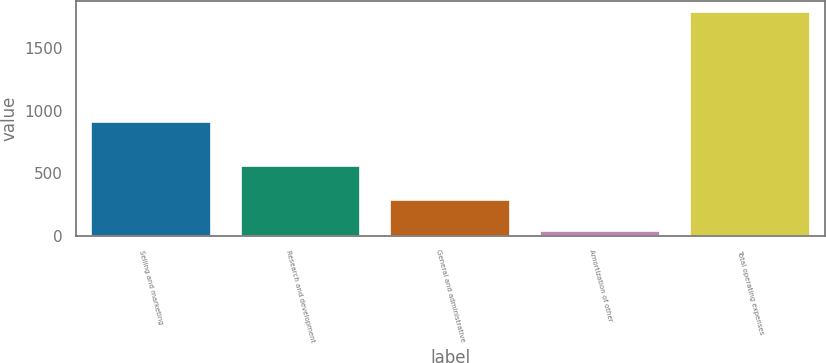Convert chart. <chart><loc_0><loc_0><loc_500><loc_500><bar_chart><fcel>Selling and marketing<fcel>Research and development<fcel>General and administrative<fcel>Amortization of other<fcel>Total operating expenses<nl><fcel>907<fcel>556<fcel>284<fcel>42<fcel>1789<nl></chart> 